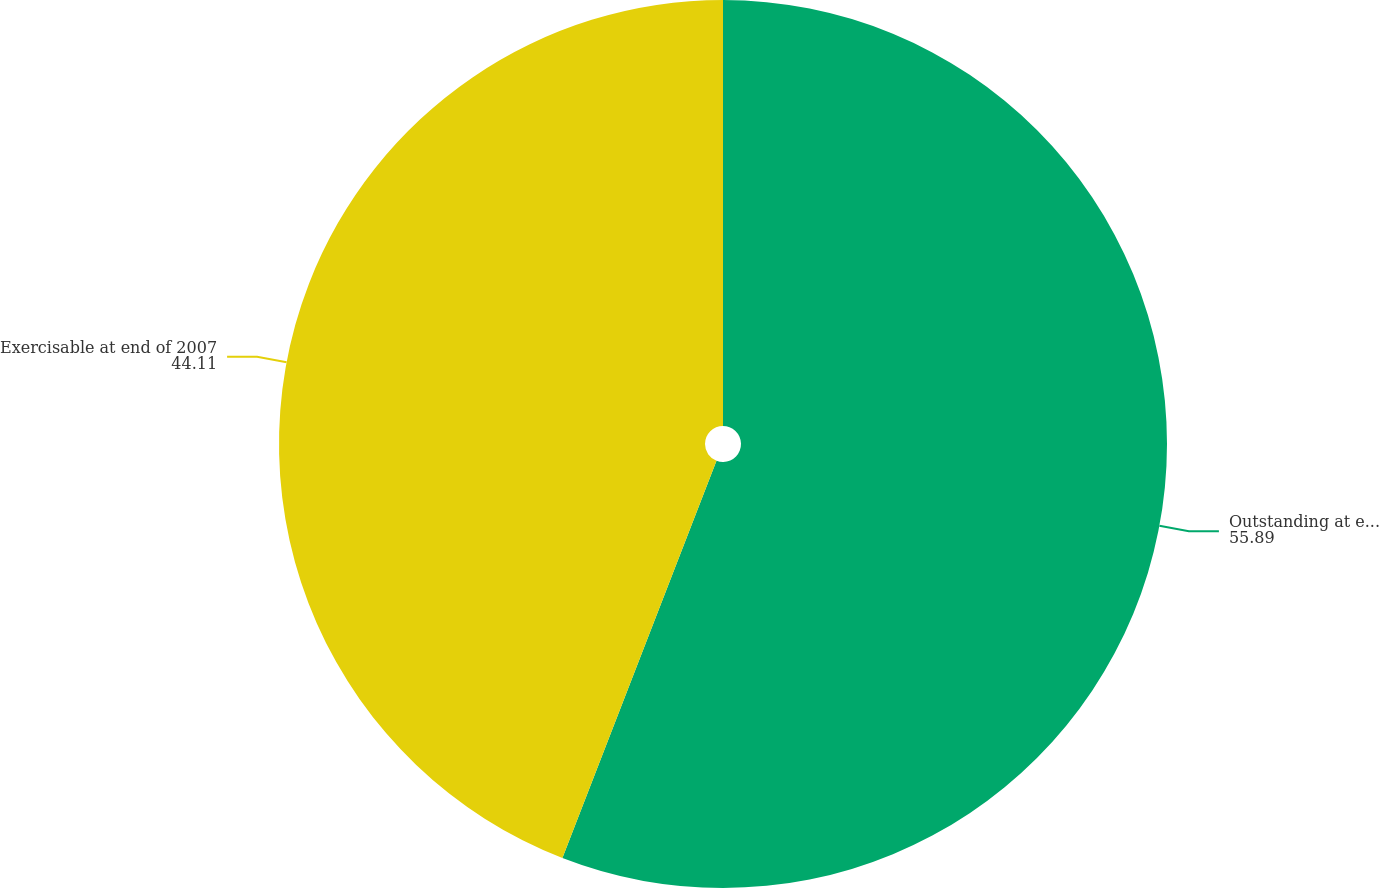Convert chart to OTSL. <chart><loc_0><loc_0><loc_500><loc_500><pie_chart><fcel>Outstanding at end of 2007<fcel>Exercisable at end of 2007<nl><fcel>55.89%<fcel>44.11%<nl></chart> 